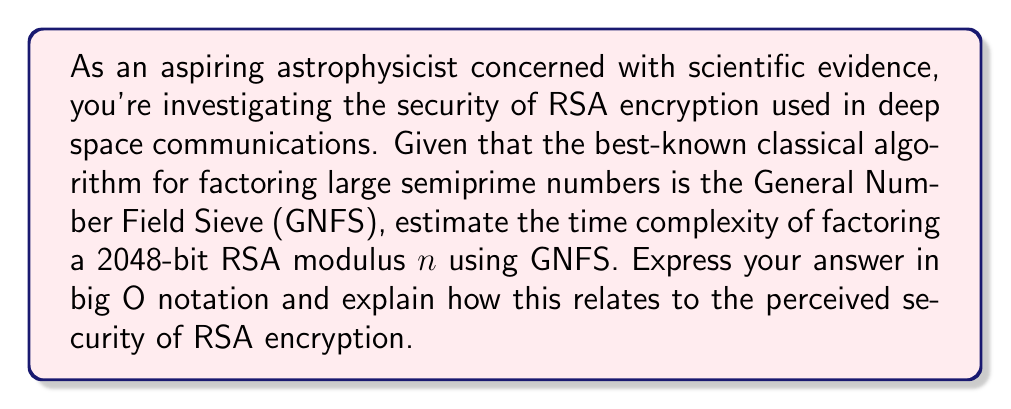Provide a solution to this math problem. To evaluate the computational complexity of factoring large semiprime numbers used in RSA encryption, we need to consider the General Number Field Sieve (GNFS) algorithm, which is currently the most efficient known method for factoring large integers.

Step 1: Understand the GNFS complexity
The time complexity of GNFS for factoring an integer $n$ is:

$$O(e^{((64/9)^{1/3} + o(1)) (\ln n)^{1/3} (\ln \ln n)^{2/3}})$$

Step 2: Simplify the expression for practical use
For cryptographic purposes, we often use a simpler approximation:

$$O(L_n[1/3, (64/9)^{1/3}])$$

Where $L_n[a,b]$ is defined as:

$$L_n[a,b] = e^{(b + o(1))(\ln n)^a (\ln \ln n)^{1-a}}$$

Step 3: Apply to a 2048-bit RSA modulus
For a 2048-bit RSA modulus, $n$ is approximately $2^{2048}$. Substituting this into our complexity formula:

$$O(L_{2^{2048}}[1/3, (64/9)^{1/3}])$$

Step 4: Interpret the result
This complexity is sub-exponential but super-polynomial, making it infeasible to factor 2048-bit RSA moduli with current classical computing technology. The security of RSA relies on this computational difficulty.

Step 5: Relate to RSA security
The time complexity demonstrates why RSA with sufficiently large key sizes (like 2048 bits) is considered secure against classical factoring attacks. However, it's important to note that quantum computers using Shor's algorithm could potentially factor these numbers in polynomial time, which would compromise RSA security.
Answer: $O(L_{2^{2048}}[1/3, (64/9)^{1/3}])$ 